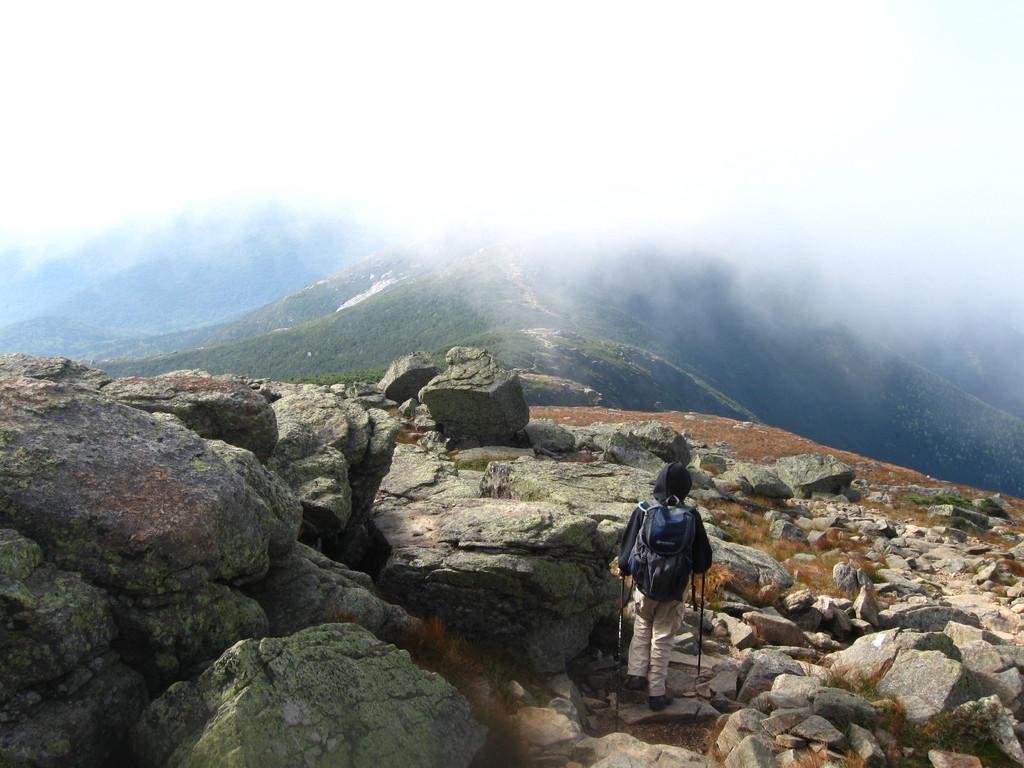Please provide a concise description of this image. This image is taken outdoors. At the bottom of the image there are many rocks and stones on the ground. In the middle of the image a person is walking on the ground. In the background there are a few hills. At the top of the image there is a sky. 